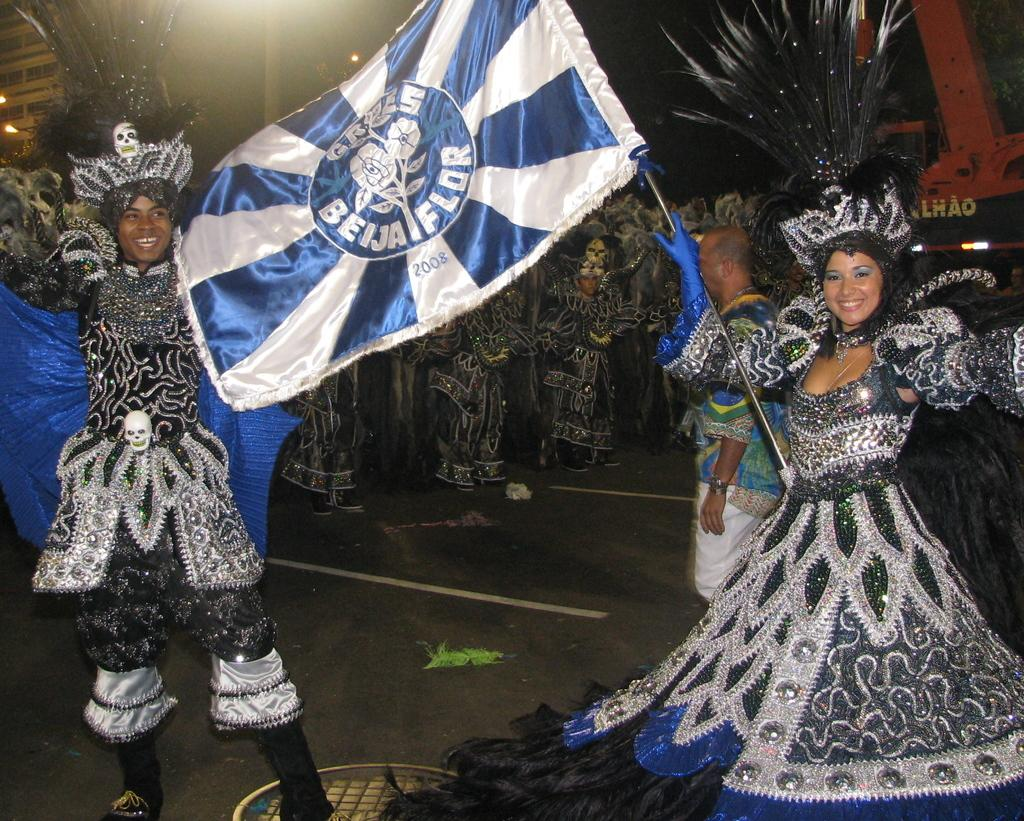What are the people in the image wearing? The people in the image are wearing costumes. What is the lady holding in the image? The lady is holding a flag in the image. Where are the people located in the image? The people are on the road in the image. What type of jam is being spread on the stomach of the person in the image? There is no jam or stomach present in the image; the people are wearing costumes and the lady is holding a flag. 